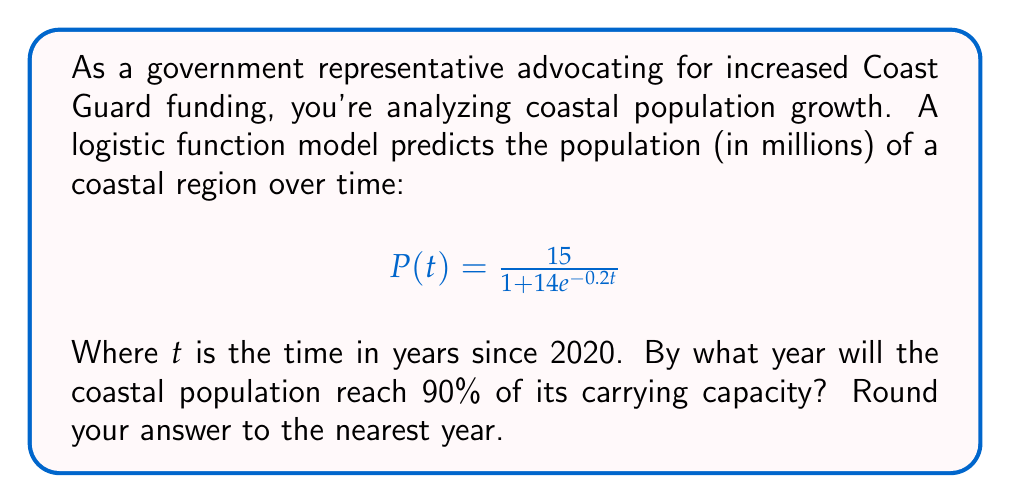Give your solution to this math problem. 1) First, let's identify the carrying capacity (K) of this logistic function:
   $$K = 15$$ million people

2) We need to find when the population reaches 90% of K:
   $$0.90K = 0.90 \times 15 = 13.5$$ million people

3) Now, we set up the equation:
   $$13.5 = \frac{15}{1 + 14e^{-0.2t}}$$

4) Solve for t:
   $$1 + 14e^{-0.2t} = \frac{15}{13.5}$$
   $$14e^{-0.2t} = \frac{15}{13.5} - 1 = \frac{1}{9}$$
   $$e^{-0.2t} = \frac{1}{126}$$

5) Take the natural log of both sides:
   $$-0.2t = \ln(\frac{1}{126})$$
   $$t = -\frac{\ln(\frac{1}{126})}{0.2}$$

6) Calculate:
   $$t \approx 24.04$$ years

7) Since 2020 is our starting point, add 24 years to get 2044.
Answer: 2044 